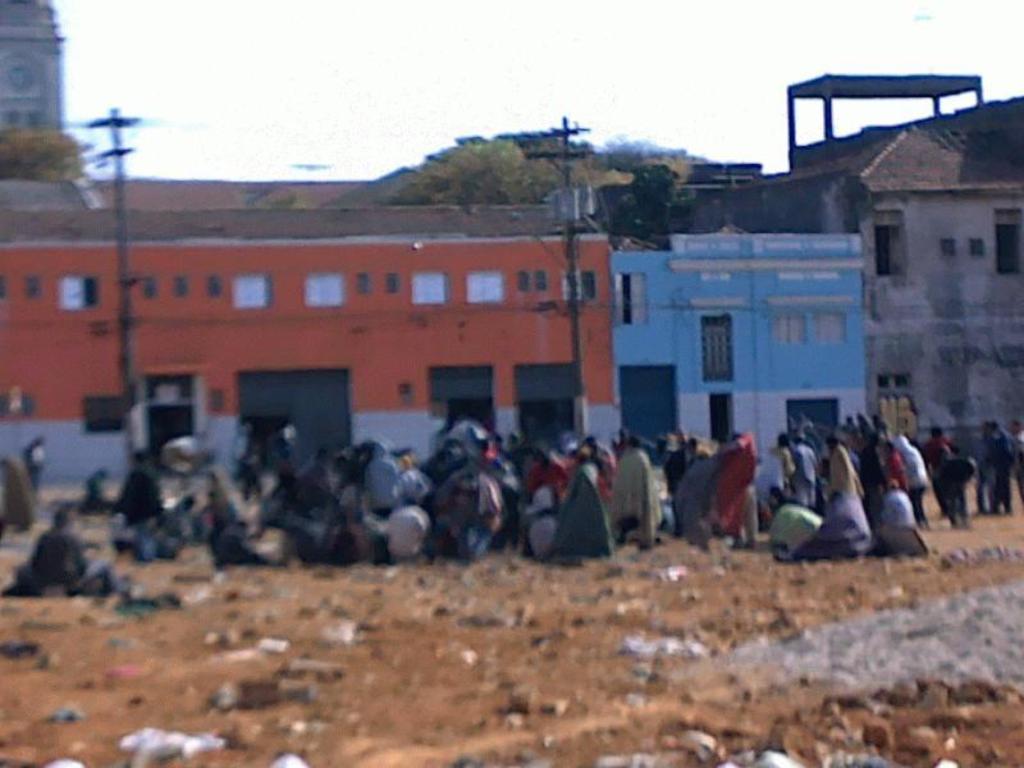How would you summarize this image in a sentence or two? In this image I can see few people are sitting and few are standing on the ground. In the background there are some buildings, poles and trees. On the top of the image I can see the sky. 